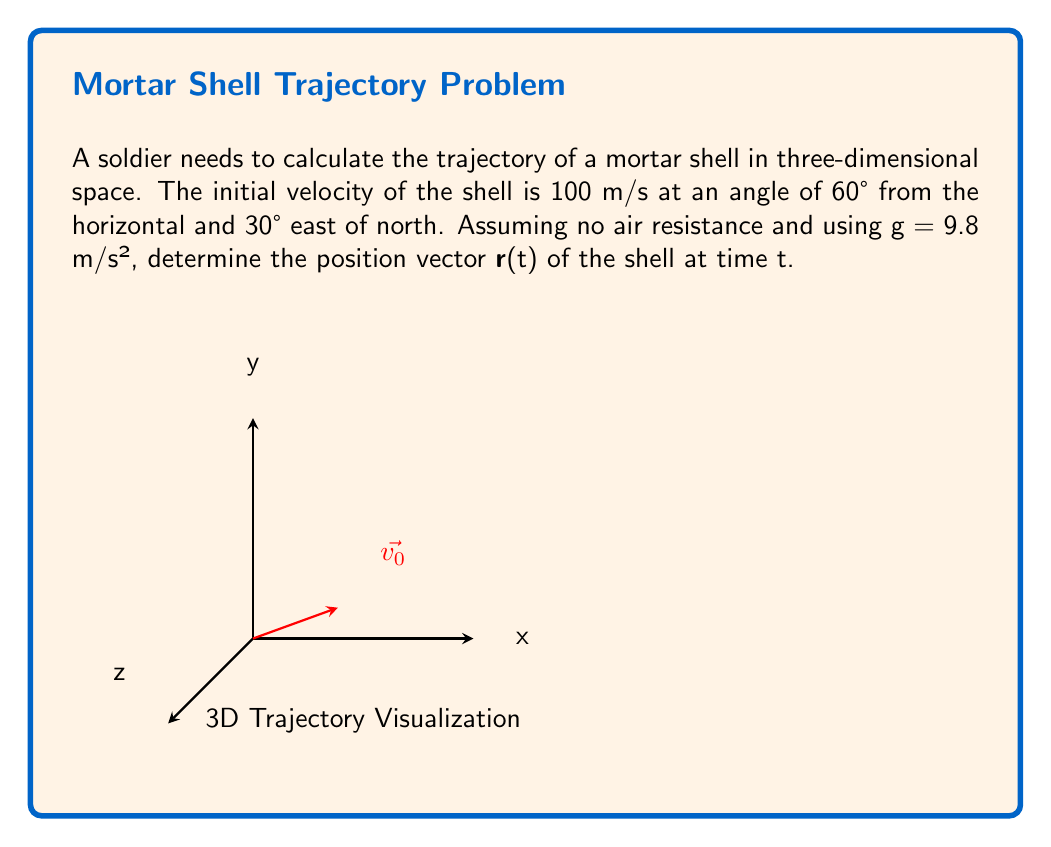Give your solution to this math problem. Let's approach this step-by-step:

1) First, we need to break down the initial velocity into its x, y, and z components:

   $v_{0x} = v_0 \cos(60°) \cos(30°)$
   $v_{0y} = v_0 \cos(60°) \sin(30°)$
   $v_{0z} = v_0 \sin(60°)$

2) Substituting $v_0 = 100$ m/s:

   $v_{0x} = 100 \cdot 0.5 \cdot \frac{\sqrt{3}}{2} = 25\sqrt{3}$ m/s
   $v_{0y} = 100 \cdot 0.5 \cdot 0.5 = 25$ m/s
   $v_{0z} = 100 \cdot \frac{\sqrt{3}}{2} = 50\sqrt{3}$ m/s

3) Now, we can use the equations of motion for each component:

   $x(t) = x_0 + v_{0x}t$
   $y(t) = y_0 + v_{0y}t$
   $z(t) = z_0 + v_{0z}t - \frac{1}{2}gt^2$

4) Assuming the initial position is the origin (0,0,0):

   $x(t) = 25\sqrt{3}t$
   $y(t) = 25t$
   $z(t) = 50\sqrt{3}t - 4.9t^2$

5) Therefore, the position vector r(t) is:

   $\mathbf{r}(t) = \langle 25\sqrt{3}t, 25t, 50\sqrt{3}t - 4.9t^2 \rangle$
Answer: $\mathbf{r}(t) = \langle 25\sqrt{3}t, 25t, 50\sqrt{3}t - 4.9t^2 \rangle$ 